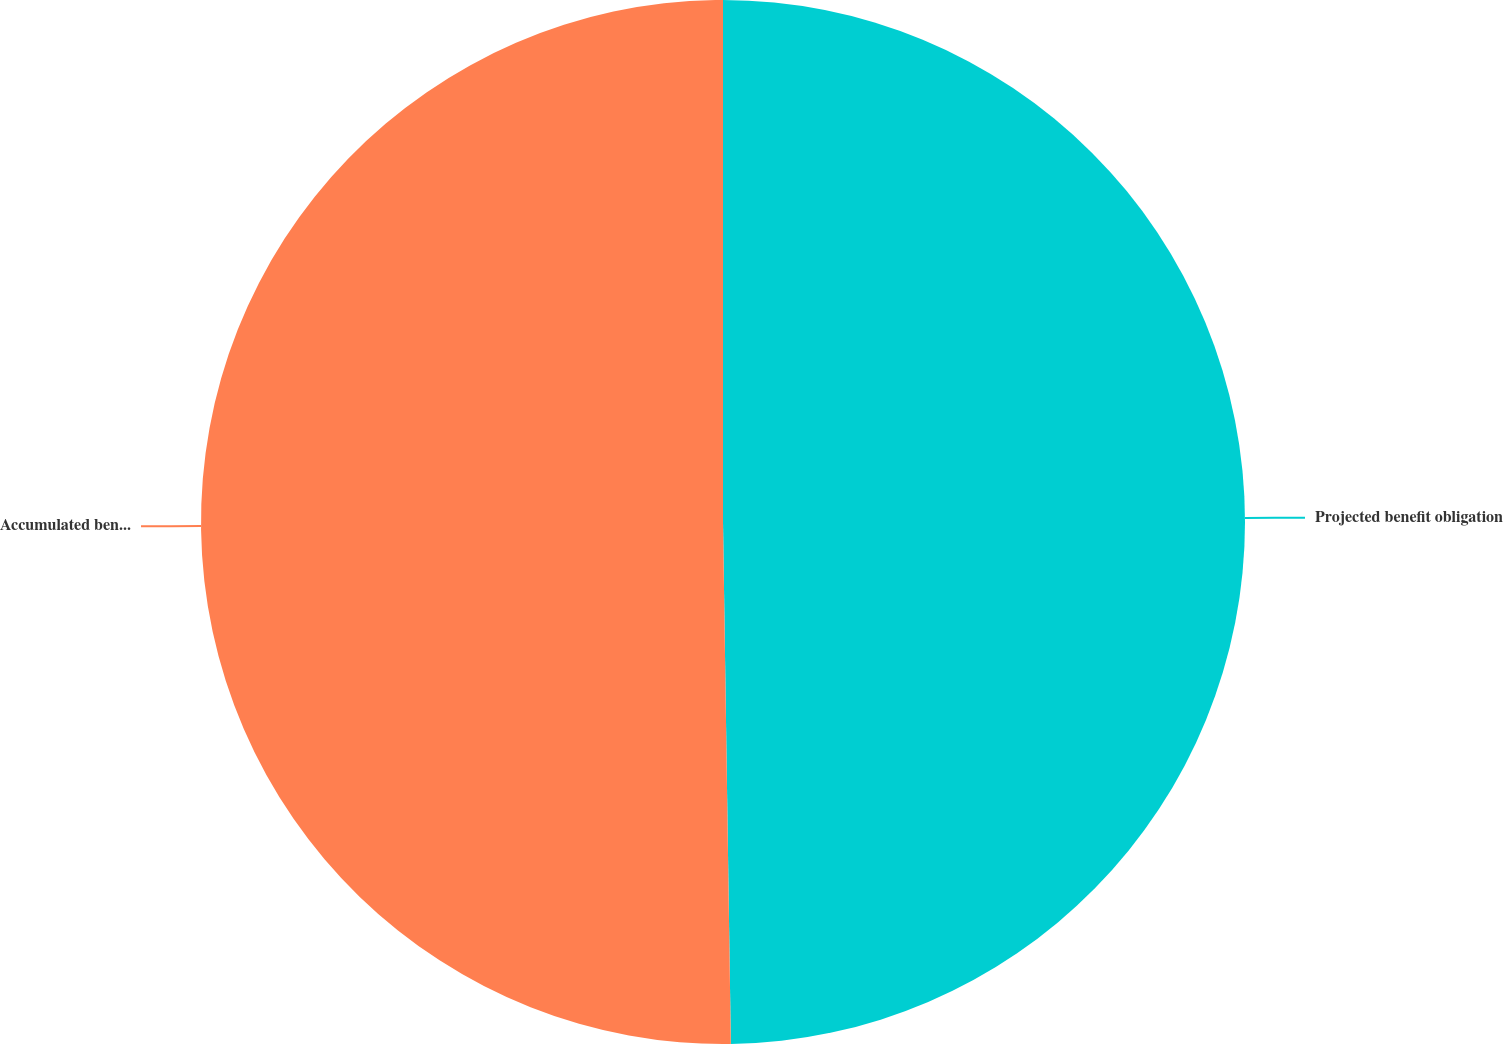<chart> <loc_0><loc_0><loc_500><loc_500><pie_chart><fcel>Projected benefit obligation<fcel>Accumulated benefit obligation<nl><fcel>49.76%<fcel>50.24%<nl></chart> 